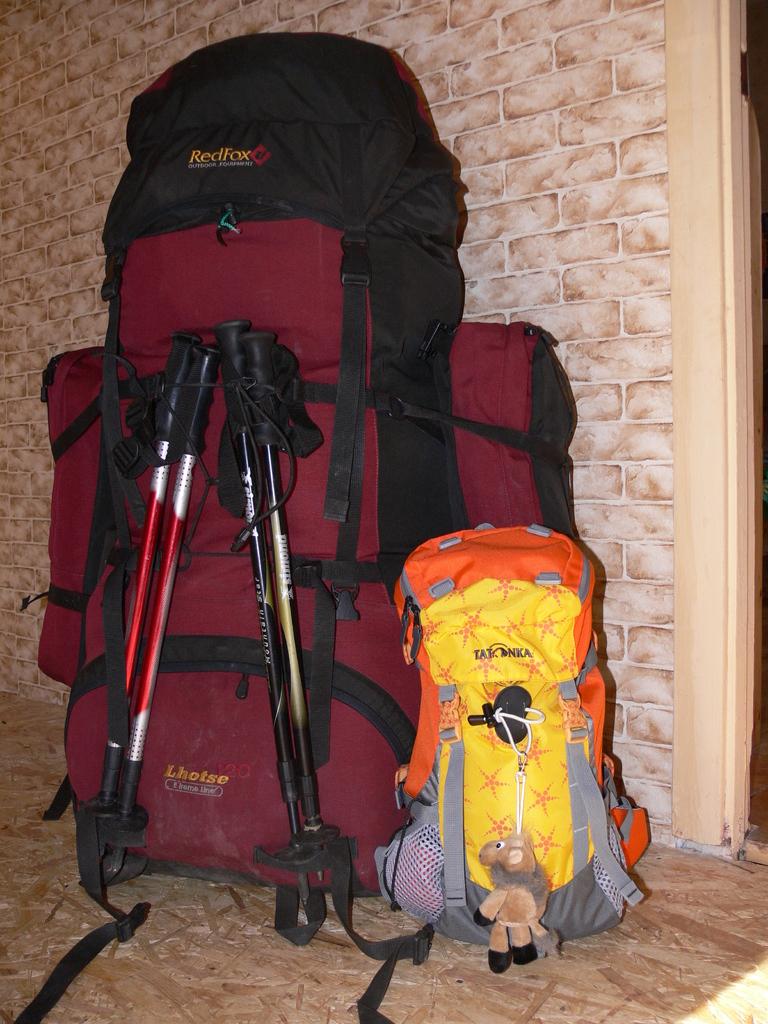What brand is the red backpack?
Give a very brief answer. Redfox. 